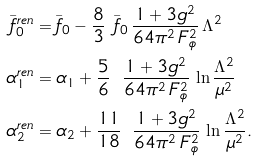Convert formula to latex. <formula><loc_0><loc_0><loc_500><loc_500>\bar { f } _ { 0 } ^ { r e n } & = \bar { f } _ { 0 } - \frac { 8 } { 3 } \ \bar { f } _ { 0 } \, \frac { 1 + 3 g ^ { 2 } } { 6 4 \pi ^ { 2 } \, F _ { \phi } ^ { 2 } } \, \Lambda ^ { 2 } \\ \alpha _ { 1 } ^ { r e n } & = \alpha _ { 1 } + \frac { 5 } { 6 } \ \, \frac { 1 + 3 g ^ { 2 } } { 6 4 \pi ^ { 2 } \, F _ { \phi } ^ { 2 } } \, \ln \frac { \Lambda ^ { 2 } } { \mu ^ { 2 } } \\ \alpha _ { 2 } ^ { r e n } & = \alpha _ { 2 } + \frac { 1 1 } { 1 8 } \ \, \frac { 1 + 3 g ^ { 2 } } { 6 4 \pi ^ { 2 } \, F _ { \phi } ^ { 2 } } \, \ln \frac { \Lambda ^ { 2 } } { \mu ^ { 2 } } .</formula> 